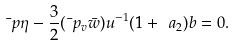Convert formula to latex. <formula><loc_0><loc_0><loc_500><loc_500>\bar { \ } p \eta - \frac { 3 } { 2 } ( \bar { \ } p _ { v } \bar { w } ) u ^ { - 1 } ( 1 + \ a _ { 2 } ) b = 0 .</formula> 